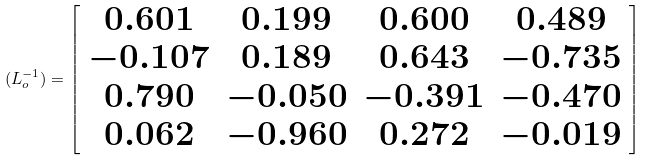<formula> <loc_0><loc_0><loc_500><loc_500>( L _ { o } ^ { - 1 } ) = \left [ \begin{array} { c c c c } 0 . 6 0 1 & 0 . 1 9 9 & 0 . 6 0 0 & 0 . 4 8 9 \\ - 0 . 1 0 7 & 0 . 1 8 9 & 0 . 6 4 3 & - 0 . 7 3 5 \\ 0 . 7 9 0 & - 0 . 0 5 0 & - 0 . 3 9 1 & - 0 . 4 7 0 \\ 0 . 0 6 2 & - 0 . 9 6 0 & 0 . 2 7 2 & - 0 . 0 1 9 \\ \end{array} \right ]</formula> 